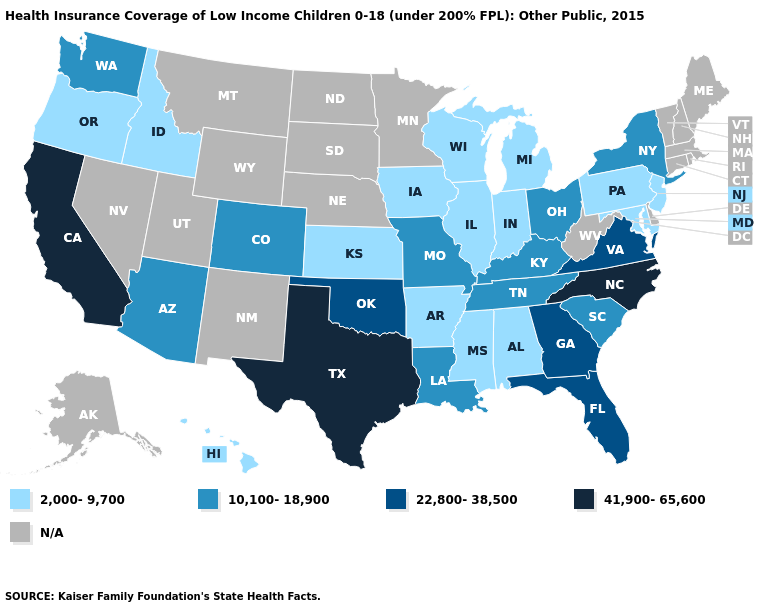Among the states that border West Virginia , which have the lowest value?
Give a very brief answer. Maryland, Pennsylvania. Name the states that have a value in the range 41,900-65,600?
Answer briefly. California, North Carolina, Texas. Among the states that border New Mexico , does Texas have the lowest value?
Write a very short answer. No. What is the lowest value in states that border Georgia?
Write a very short answer. 2,000-9,700. What is the value of Delaware?
Give a very brief answer. N/A. What is the highest value in the USA?
Keep it brief. 41,900-65,600. What is the highest value in the USA?
Answer briefly. 41,900-65,600. Which states hav the highest value in the MidWest?
Quick response, please. Missouri, Ohio. Does New York have the lowest value in the USA?
Keep it brief. No. Among the states that border North Carolina , which have the lowest value?
Quick response, please. South Carolina, Tennessee. What is the lowest value in the MidWest?
Write a very short answer. 2,000-9,700. What is the lowest value in states that border South Dakota?
Answer briefly. 2,000-9,700. What is the highest value in the West ?
Keep it brief. 41,900-65,600. Does Washington have the lowest value in the USA?
Short answer required. No. Does the map have missing data?
Be succinct. Yes. 